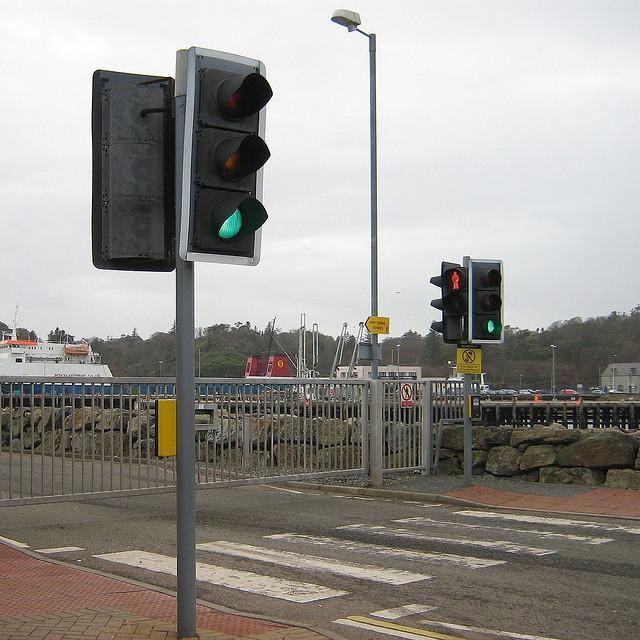How many traffic lights are there?
Give a very brief answer. 4. How many horses are in the photo?
Give a very brief answer. 0. 